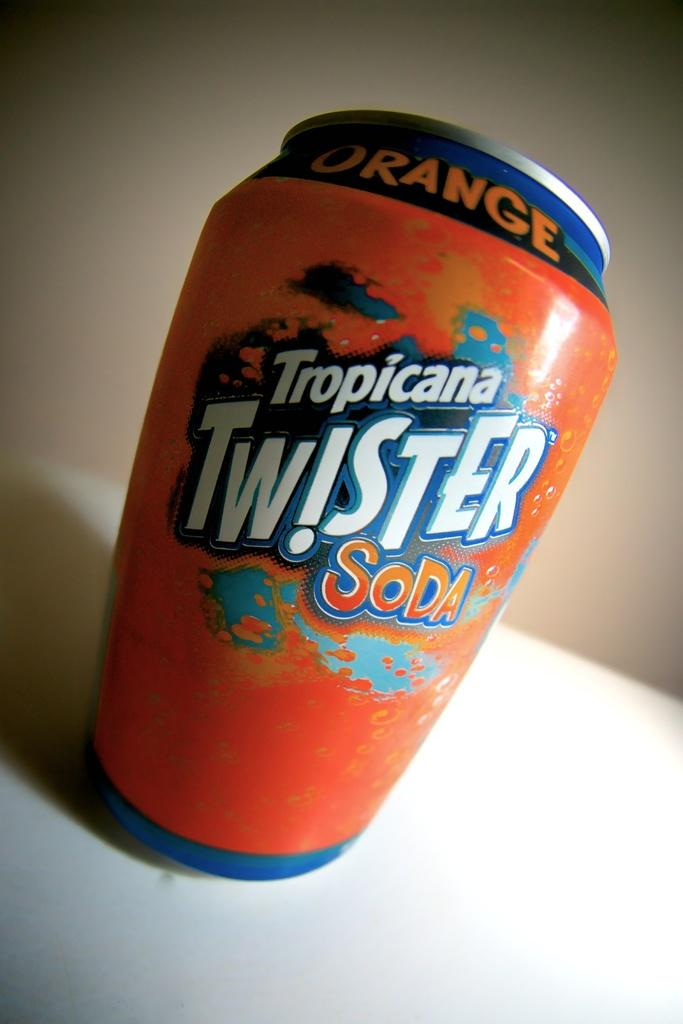<image>
Provide a brief description of the given image. Tropicana Twister Soda comes in a bright orange can. 